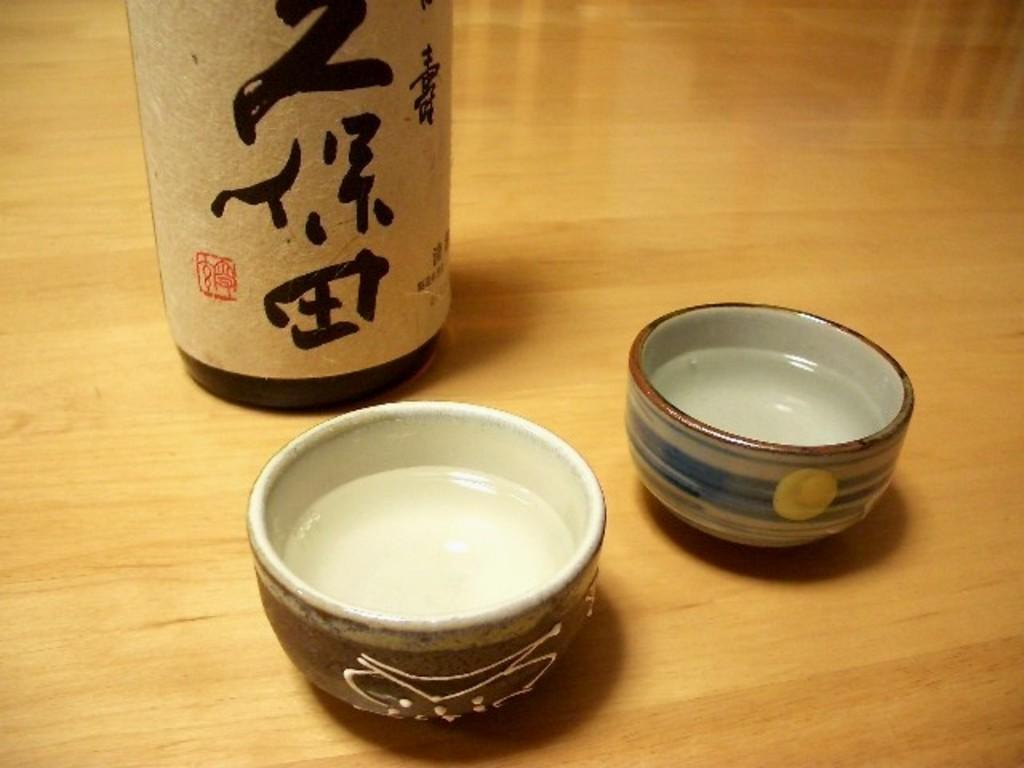What can be seen in the two bowls in the image? There are two bowls with liquids in the image. What is the surface that the bowls are placed on? The bowls are on a wooden surface. Can you describe any other objects partially visible in the image? There is a partial view of a bottle in the image. How many feet can be seen in the image? There are no feet visible in the image. Is there a giraffe in the image? No, there is no giraffe present in the image. 